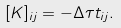Convert formula to latex. <formula><loc_0><loc_0><loc_500><loc_500>[ K ] _ { i j } = - \Delta \tau t _ { i j } .</formula> 